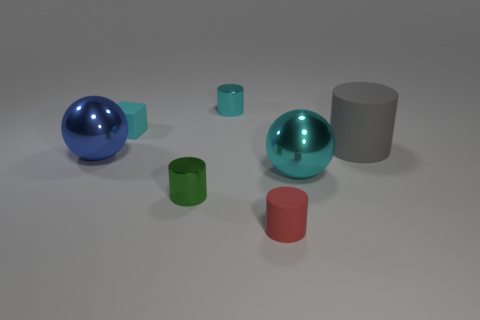Add 1 red cylinders. How many objects exist? 8 Subtract all small green shiny cylinders. How many cylinders are left? 3 Subtract all cubes. How many objects are left? 6 Subtract all red cylinders. How many cylinders are left? 3 Subtract 4 cylinders. How many cylinders are left? 0 Subtract 0 brown spheres. How many objects are left? 7 Subtract all brown cylinders. Subtract all green cubes. How many cylinders are left? 4 Subtract all large brown spheres. Subtract all big gray matte cylinders. How many objects are left? 6 Add 7 big objects. How many big objects are left? 10 Add 2 red rubber cylinders. How many red rubber cylinders exist? 3 